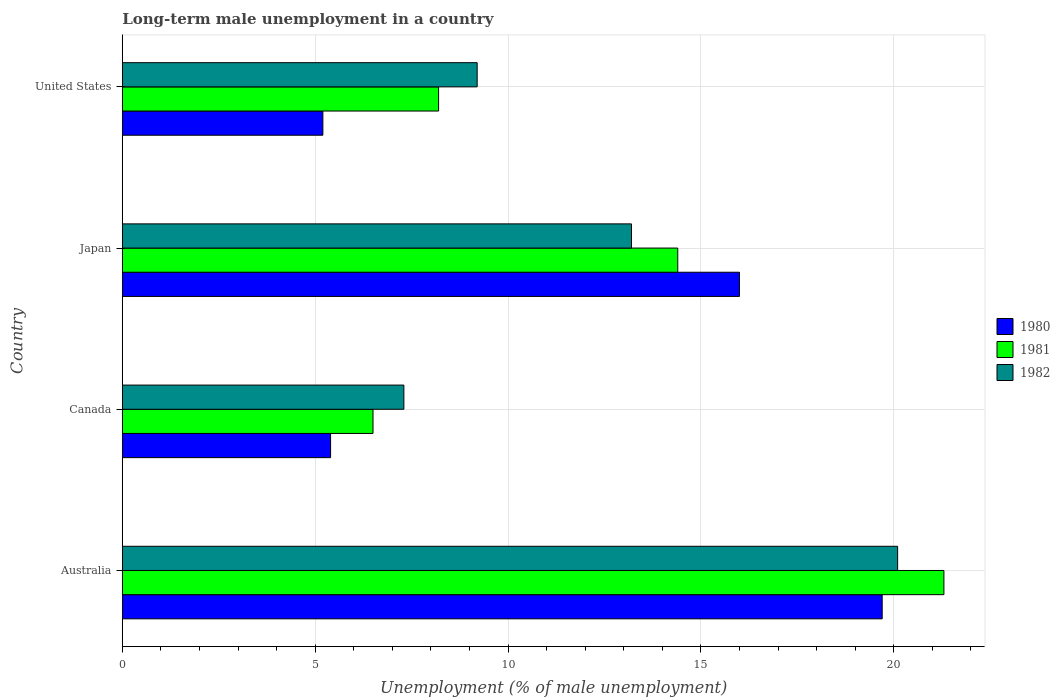How many bars are there on the 3rd tick from the top?
Offer a terse response. 3. How many bars are there on the 1st tick from the bottom?
Provide a succinct answer. 3. In how many cases, is the number of bars for a given country not equal to the number of legend labels?
Provide a short and direct response. 0. What is the percentage of long-term unemployed male population in 1982 in Japan?
Offer a very short reply. 13.2. Across all countries, what is the maximum percentage of long-term unemployed male population in 1982?
Your answer should be very brief. 20.1. In which country was the percentage of long-term unemployed male population in 1982 maximum?
Ensure brevity in your answer.  Australia. In which country was the percentage of long-term unemployed male population in 1980 minimum?
Offer a terse response. United States. What is the total percentage of long-term unemployed male population in 1982 in the graph?
Provide a short and direct response. 49.8. What is the difference between the percentage of long-term unemployed male population in 1981 in Canada and that in United States?
Your answer should be very brief. -1.7. What is the difference between the percentage of long-term unemployed male population in 1981 in Canada and the percentage of long-term unemployed male population in 1982 in United States?
Give a very brief answer. -2.7. What is the average percentage of long-term unemployed male population in 1981 per country?
Provide a succinct answer. 12.6. What is the difference between the percentage of long-term unemployed male population in 1981 and percentage of long-term unemployed male population in 1982 in United States?
Provide a succinct answer. -1. What is the ratio of the percentage of long-term unemployed male population in 1981 in Japan to that in United States?
Make the answer very short. 1.76. Is the difference between the percentage of long-term unemployed male population in 1981 in Australia and United States greater than the difference between the percentage of long-term unemployed male population in 1982 in Australia and United States?
Your answer should be compact. Yes. What is the difference between the highest and the second highest percentage of long-term unemployed male population in 1980?
Give a very brief answer. 3.7. What is the difference between the highest and the lowest percentage of long-term unemployed male population in 1982?
Offer a very short reply. 12.8. In how many countries, is the percentage of long-term unemployed male population in 1980 greater than the average percentage of long-term unemployed male population in 1980 taken over all countries?
Ensure brevity in your answer.  2. Is the sum of the percentage of long-term unemployed male population in 1980 in Australia and United States greater than the maximum percentage of long-term unemployed male population in 1981 across all countries?
Provide a short and direct response. Yes. What does the 1st bar from the top in Australia represents?
Keep it short and to the point. 1982. What does the 1st bar from the bottom in Canada represents?
Keep it short and to the point. 1980. Is it the case that in every country, the sum of the percentage of long-term unemployed male population in 1981 and percentage of long-term unemployed male population in 1980 is greater than the percentage of long-term unemployed male population in 1982?
Keep it short and to the point. Yes. Are all the bars in the graph horizontal?
Keep it short and to the point. Yes. What is the difference between two consecutive major ticks on the X-axis?
Your response must be concise. 5. Does the graph contain any zero values?
Your response must be concise. No. Does the graph contain grids?
Your response must be concise. Yes. How many legend labels are there?
Your answer should be very brief. 3. How are the legend labels stacked?
Your response must be concise. Vertical. What is the title of the graph?
Keep it short and to the point. Long-term male unemployment in a country. Does "2009" appear as one of the legend labels in the graph?
Give a very brief answer. No. What is the label or title of the X-axis?
Offer a very short reply. Unemployment (% of male unemployment). What is the label or title of the Y-axis?
Keep it short and to the point. Country. What is the Unemployment (% of male unemployment) in 1980 in Australia?
Keep it short and to the point. 19.7. What is the Unemployment (% of male unemployment) in 1981 in Australia?
Provide a succinct answer. 21.3. What is the Unemployment (% of male unemployment) in 1982 in Australia?
Give a very brief answer. 20.1. What is the Unemployment (% of male unemployment) of 1980 in Canada?
Your answer should be very brief. 5.4. What is the Unemployment (% of male unemployment) in 1981 in Canada?
Make the answer very short. 6.5. What is the Unemployment (% of male unemployment) of 1982 in Canada?
Offer a terse response. 7.3. What is the Unemployment (% of male unemployment) in 1980 in Japan?
Your response must be concise. 16. What is the Unemployment (% of male unemployment) in 1981 in Japan?
Provide a short and direct response. 14.4. What is the Unemployment (% of male unemployment) of 1982 in Japan?
Your response must be concise. 13.2. What is the Unemployment (% of male unemployment) of 1980 in United States?
Your answer should be compact. 5.2. What is the Unemployment (% of male unemployment) of 1981 in United States?
Your answer should be very brief. 8.2. What is the Unemployment (% of male unemployment) in 1982 in United States?
Offer a very short reply. 9.2. Across all countries, what is the maximum Unemployment (% of male unemployment) of 1980?
Provide a short and direct response. 19.7. Across all countries, what is the maximum Unemployment (% of male unemployment) of 1981?
Your response must be concise. 21.3. Across all countries, what is the maximum Unemployment (% of male unemployment) of 1982?
Your answer should be very brief. 20.1. Across all countries, what is the minimum Unemployment (% of male unemployment) of 1980?
Your response must be concise. 5.2. Across all countries, what is the minimum Unemployment (% of male unemployment) of 1982?
Ensure brevity in your answer.  7.3. What is the total Unemployment (% of male unemployment) of 1980 in the graph?
Make the answer very short. 46.3. What is the total Unemployment (% of male unemployment) of 1981 in the graph?
Offer a very short reply. 50.4. What is the total Unemployment (% of male unemployment) in 1982 in the graph?
Ensure brevity in your answer.  49.8. What is the difference between the Unemployment (% of male unemployment) in 1980 in Australia and that in Canada?
Provide a short and direct response. 14.3. What is the difference between the Unemployment (% of male unemployment) in 1981 in Australia and that in Japan?
Make the answer very short. 6.9. What is the difference between the Unemployment (% of male unemployment) of 1982 in Australia and that in Japan?
Your answer should be very brief. 6.9. What is the difference between the Unemployment (% of male unemployment) of 1982 in Australia and that in United States?
Ensure brevity in your answer.  10.9. What is the difference between the Unemployment (% of male unemployment) in 1980 in Canada and that in Japan?
Give a very brief answer. -10.6. What is the difference between the Unemployment (% of male unemployment) in 1981 in Canada and that in Japan?
Offer a very short reply. -7.9. What is the difference between the Unemployment (% of male unemployment) of 1982 in Canada and that in Japan?
Offer a terse response. -5.9. What is the difference between the Unemployment (% of male unemployment) in 1981 in Canada and that in United States?
Your answer should be very brief. -1.7. What is the difference between the Unemployment (% of male unemployment) in 1980 in Japan and that in United States?
Your response must be concise. 10.8. What is the difference between the Unemployment (% of male unemployment) of 1981 in Japan and that in United States?
Make the answer very short. 6.2. What is the difference between the Unemployment (% of male unemployment) of 1982 in Japan and that in United States?
Ensure brevity in your answer.  4. What is the difference between the Unemployment (% of male unemployment) of 1980 in Australia and the Unemployment (% of male unemployment) of 1981 in Canada?
Make the answer very short. 13.2. What is the difference between the Unemployment (% of male unemployment) of 1981 in Australia and the Unemployment (% of male unemployment) of 1982 in Canada?
Provide a succinct answer. 14. What is the difference between the Unemployment (% of male unemployment) in 1980 in Australia and the Unemployment (% of male unemployment) in 1982 in Japan?
Provide a short and direct response. 6.5. What is the difference between the Unemployment (% of male unemployment) of 1981 in Australia and the Unemployment (% of male unemployment) of 1982 in Japan?
Give a very brief answer. 8.1. What is the difference between the Unemployment (% of male unemployment) in 1981 in Australia and the Unemployment (% of male unemployment) in 1982 in United States?
Ensure brevity in your answer.  12.1. What is the difference between the Unemployment (% of male unemployment) in 1980 in Canada and the Unemployment (% of male unemployment) in 1982 in Japan?
Give a very brief answer. -7.8. What is the difference between the Unemployment (% of male unemployment) in 1980 in Canada and the Unemployment (% of male unemployment) in 1981 in United States?
Your answer should be very brief. -2.8. What is the difference between the Unemployment (% of male unemployment) of 1980 in Canada and the Unemployment (% of male unemployment) of 1982 in United States?
Your response must be concise. -3.8. What is the difference between the Unemployment (% of male unemployment) of 1981 in Canada and the Unemployment (% of male unemployment) of 1982 in United States?
Your response must be concise. -2.7. What is the average Unemployment (% of male unemployment) of 1980 per country?
Give a very brief answer. 11.57. What is the average Unemployment (% of male unemployment) in 1982 per country?
Give a very brief answer. 12.45. What is the difference between the Unemployment (% of male unemployment) in 1981 and Unemployment (% of male unemployment) in 1982 in Australia?
Offer a very short reply. 1.2. What is the difference between the Unemployment (% of male unemployment) in 1980 and Unemployment (% of male unemployment) in 1981 in Canada?
Ensure brevity in your answer.  -1.1. What is the difference between the Unemployment (% of male unemployment) of 1981 and Unemployment (% of male unemployment) of 1982 in Japan?
Make the answer very short. 1.2. What is the difference between the Unemployment (% of male unemployment) in 1980 and Unemployment (% of male unemployment) in 1982 in United States?
Your answer should be very brief. -4. What is the ratio of the Unemployment (% of male unemployment) of 1980 in Australia to that in Canada?
Ensure brevity in your answer.  3.65. What is the ratio of the Unemployment (% of male unemployment) of 1981 in Australia to that in Canada?
Your answer should be compact. 3.28. What is the ratio of the Unemployment (% of male unemployment) of 1982 in Australia to that in Canada?
Offer a terse response. 2.75. What is the ratio of the Unemployment (% of male unemployment) of 1980 in Australia to that in Japan?
Your answer should be compact. 1.23. What is the ratio of the Unemployment (% of male unemployment) of 1981 in Australia to that in Japan?
Give a very brief answer. 1.48. What is the ratio of the Unemployment (% of male unemployment) of 1982 in Australia to that in Japan?
Keep it short and to the point. 1.52. What is the ratio of the Unemployment (% of male unemployment) of 1980 in Australia to that in United States?
Your answer should be compact. 3.79. What is the ratio of the Unemployment (% of male unemployment) in 1981 in Australia to that in United States?
Ensure brevity in your answer.  2.6. What is the ratio of the Unemployment (% of male unemployment) in 1982 in Australia to that in United States?
Provide a short and direct response. 2.18. What is the ratio of the Unemployment (% of male unemployment) in 1980 in Canada to that in Japan?
Offer a very short reply. 0.34. What is the ratio of the Unemployment (% of male unemployment) in 1981 in Canada to that in Japan?
Provide a succinct answer. 0.45. What is the ratio of the Unemployment (% of male unemployment) in 1982 in Canada to that in Japan?
Your answer should be very brief. 0.55. What is the ratio of the Unemployment (% of male unemployment) in 1981 in Canada to that in United States?
Give a very brief answer. 0.79. What is the ratio of the Unemployment (% of male unemployment) of 1982 in Canada to that in United States?
Provide a short and direct response. 0.79. What is the ratio of the Unemployment (% of male unemployment) of 1980 in Japan to that in United States?
Your answer should be compact. 3.08. What is the ratio of the Unemployment (% of male unemployment) in 1981 in Japan to that in United States?
Provide a succinct answer. 1.76. What is the ratio of the Unemployment (% of male unemployment) of 1982 in Japan to that in United States?
Your answer should be very brief. 1.43. What is the difference between the highest and the second highest Unemployment (% of male unemployment) in 1980?
Ensure brevity in your answer.  3.7. What is the difference between the highest and the second highest Unemployment (% of male unemployment) of 1982?
Provide a short and direct response. 6.9. What is the difference between the highest and the lowest Unemployment (% of male unemployment) in 1980?
Provide a succinct answer. 14.5. What is the difference between the highest and the lowest Unemployment (% of male unemployment) of 1982?
Your response must be concise. 12.8. 